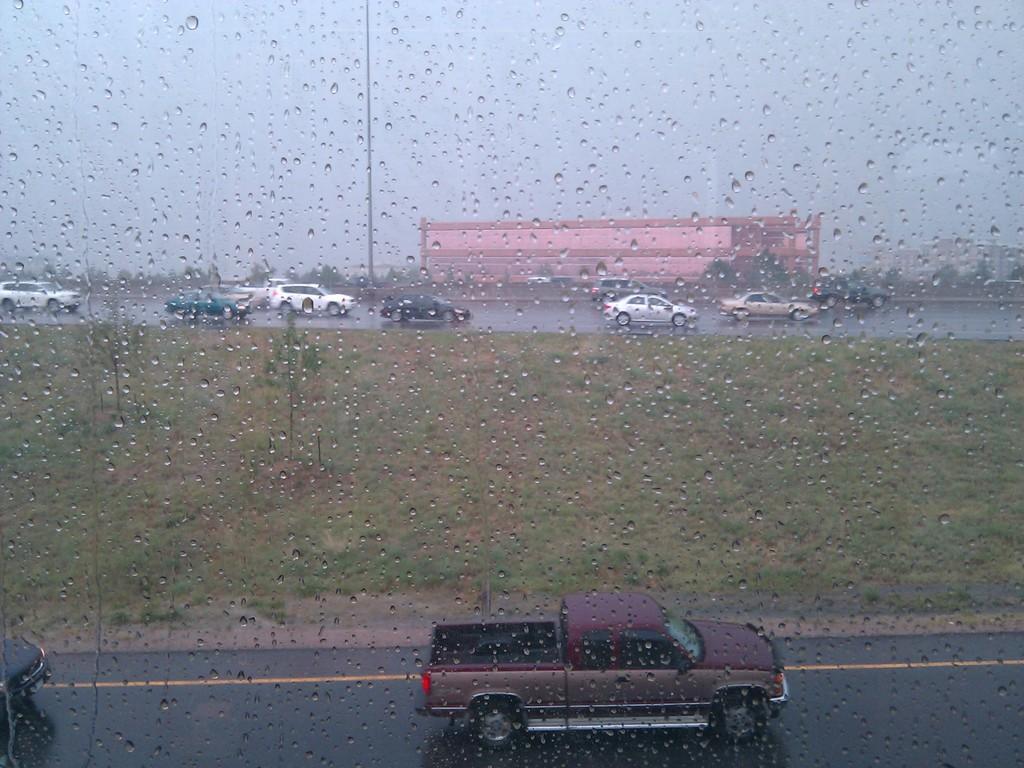In one or two sentences, can you explain what this image depicts? In this image in the front there is a glass with water drops on it. Behind the glass there are cars on the road and there are trees and buildings. 